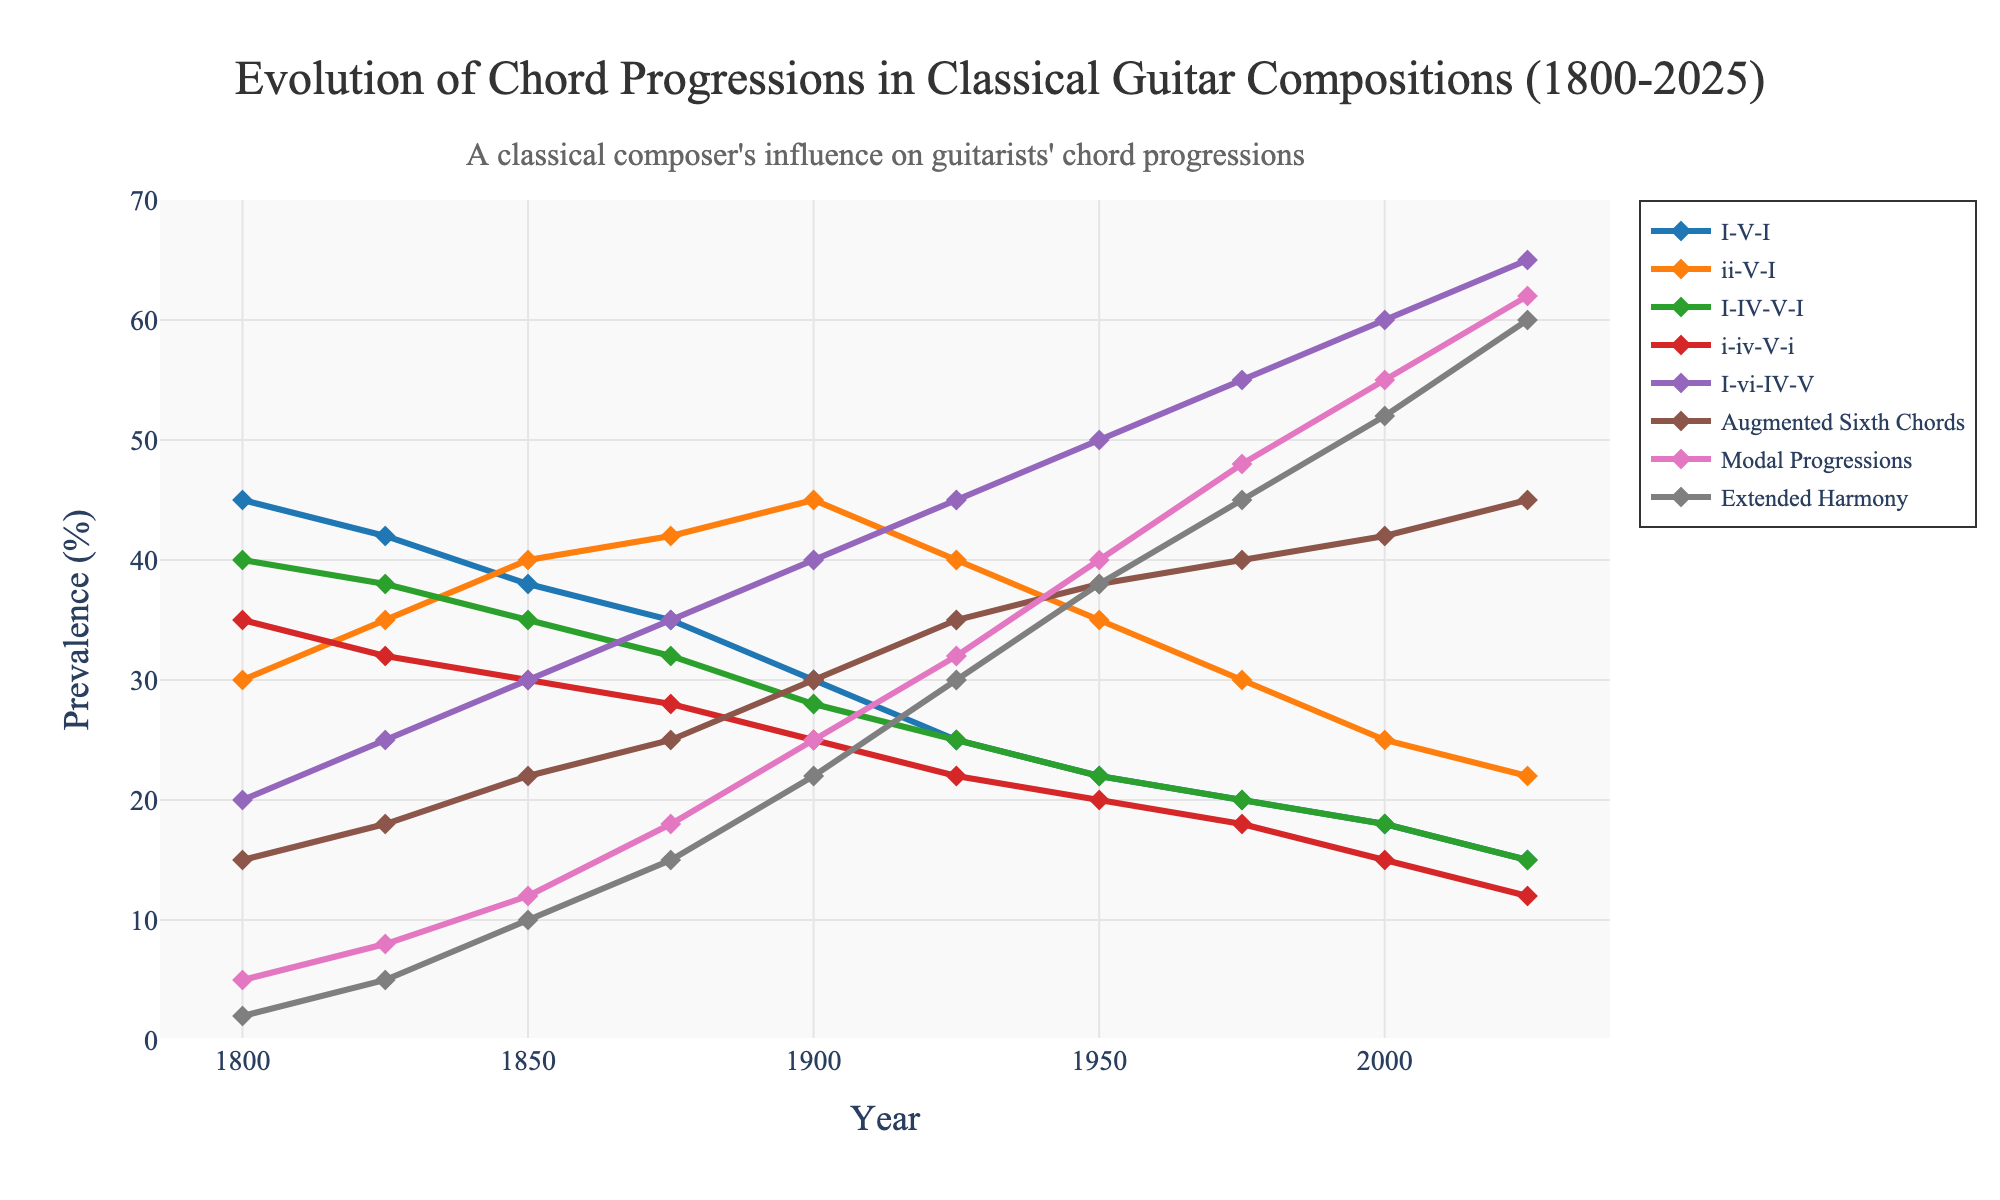Which chord progression was most prevalent in 2000? To determine the most prevalent chord progression in 2000, we look at the values for each progression and identify the highest one. In 2000, the values are: I-V-I (18), ii-V-I (25), I-IV-V-I (18), i-iv-V-i (15), I-vi-IV-V (60), Augmented Sixth Chords (42), Modal Progressions (55), Extended Harmony (52). The highest value is for I-vi-IV-V.
Answer: I-vi-IV-V How did the prevalence of Augmented Sixth Chords change from 1800 to 2025? By comparing the value of Augmented Sixth Chords in 1800 (15) with its value in 2025 (45), we note the difference. The prevalence increased by 30 percentage points from 1800 to 2025.
Answer: Increased by 30 Which chord progressions showed a consistent decrease over the years? To observe consistent decreases, we look at each chord progression trend over time: I-V-I (45 to 15), ii-V-I (30 to 22), I-IV-V-I (40 to 15), i-iv-V-i (35 to 12). All these showed a consistent decrease over the years.
Answer: I-V-I, ii-V-I, I-IV-V-I, i-iv-V-i In which year did Modal Progressions first surpass Extended Harmony in prevalence? Observing the intersection point on the graph or values, we see that until 1925, Extended Harmony was less prevalent than Modal Progressions. From 1900, Modal Progressions (25) first surpassed Extended Harmony (22).
Answer: 1900 What is the average prevalence of I-vi-IV-V between 1825 and 1950? To find the average, add the prevalence values of I-vi-IV-V for the years 1825, 1850, 1875, 1900, 1925, and 1950, then divide by the number of data points: (25 + 30 + 35 + 40 + 45 + 50) / 6 = 225 / 6 = 37.5
Answer: 37.5 Which chord progression had the highest increase in prevalence between 1975 and 2025? Subtract the values of each chord progression in 1975 from those in 2025 and find the highest difference: I-V-I (15-20), ii-V-I (22-30), I-IV-V-I (15-20), i-iv-V-i (12-18), I-vi-IV-V (65-55), Augmented Sixth Chords (45-40), Modal Progressions (62-48), Extended Harmony (60-45). The highest increase is for I-vi-IV-V (65-55=10).
Answer: I-vi-IV-V What is the total prevalence of non-common-practice chord progressions (Modal Progressions and Extended Harmony) in 2025? Sum the values of Modal Progressions (62) and Extended Harmony (60) in 2025: 62 + 60 = 122.
Answer: 122 During which period did the prevalence of I-V-I progression decline the most sharply? To identify periods of sharp decline for I-V-I, we examine the differences over time: from 1800 (45) to 1825 (42, -3), from 1825 (42) to 1850 (38, -4), from 1850 (38) to 1875 (35, -3), from 1875 (35) to 1900 (30, -5), from 1900 (30) to 1925 (25, -5), from 1925 (25) to 1950 (22, -3), from 1950 (22) to 1975 (20, -2), from 1975 (20) to 2000 (18, -2), and from 2000 (18) to 2025 (15, -3). The most significant decline occurred from 1875 to 1900 and 1900 to 1925 (both -5).
Answer: 1875 to 1925 By how many percentage points did the prevalence of Modal Progressions increase from 1850 to 2025? Subtracting the value of Modal Progressions in 1850 (12) from its value in 2025 (62): 62 - 12 = 50.
Answer: 50 